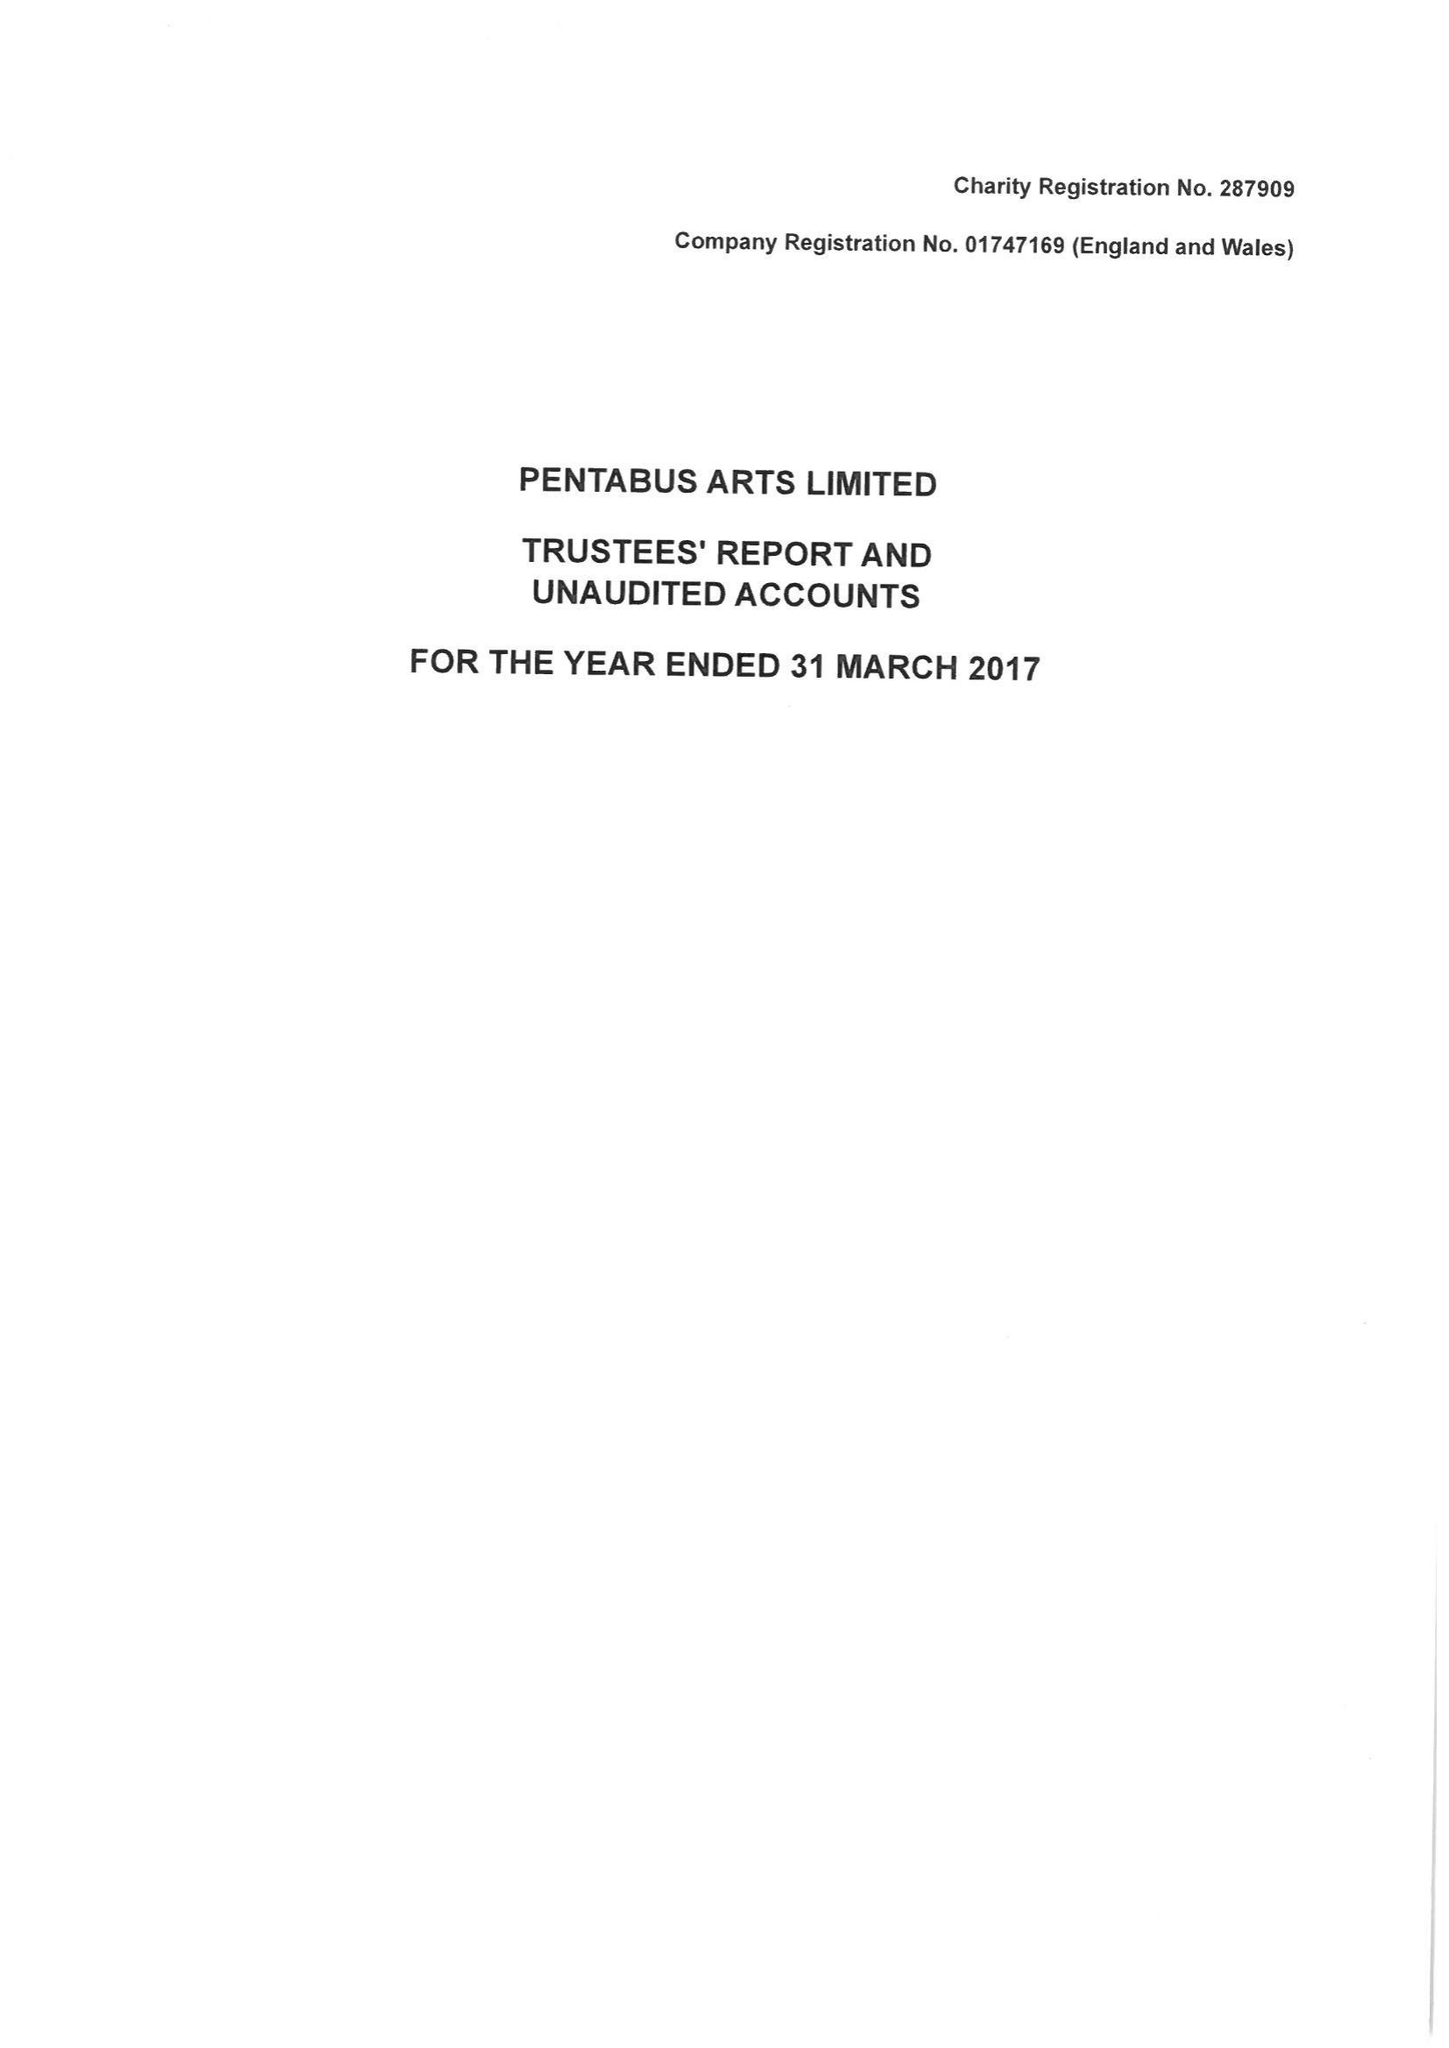What is the value for the charity_number?
Answer the question using a single word or phrase. 287909 